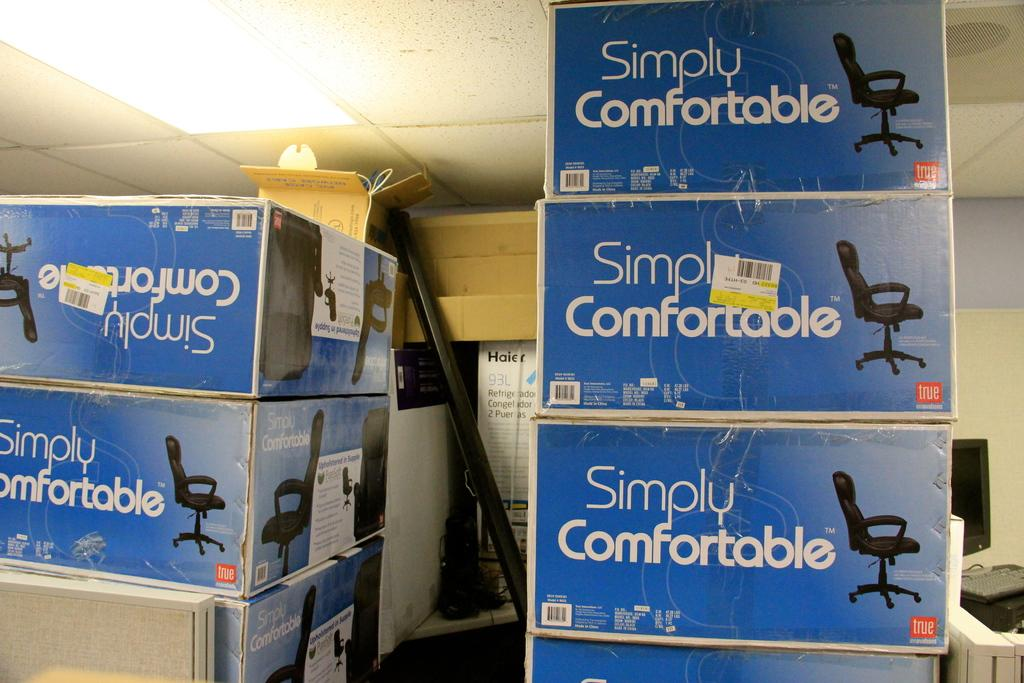<image>
Give a short and clear explanation of the subsequent image. large supply room for office computer chairs, named simply comfort 